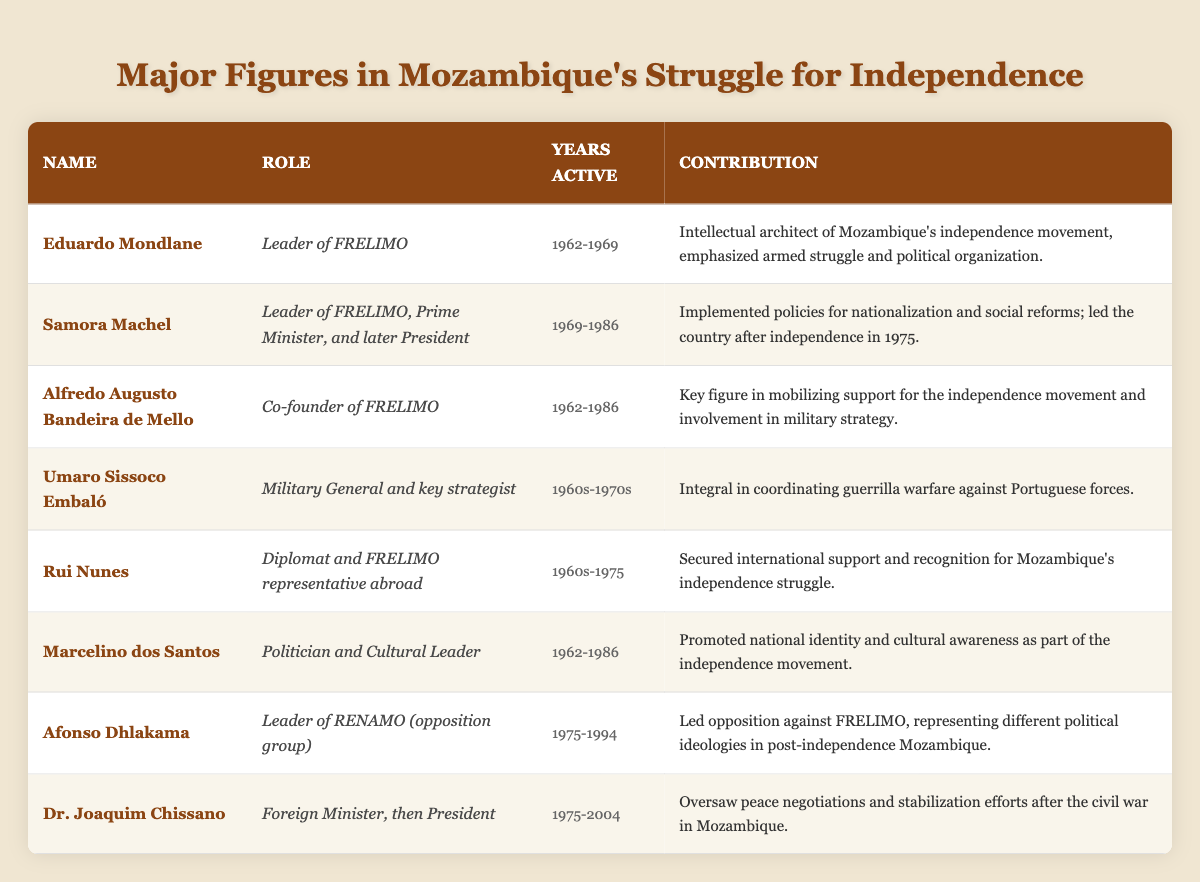What was Eduardo Mondlane's role in Mozambique's independence? According to the table, Eduardo Mondlane served as the "Leader of FRELIMO." This information is directly listed in the corresponding row for his name.
Answer: Leader of FRELIMO Who was the leader of FRELIMO after Eduardo Mondlane? The table indicates that Samora Machel succeeded Eduardo Mondlane as the leader of FRELIMO, effective from 1969, as per the time frames listed under their respective roles.
Answer: Samora Machel How many years was Afonso Dhlakama active in his role? The years active for Afonso Dhlakama are listed as 1975-1994. To find the total active years, we subtract the start year from the end year: 1994 - 1975 = 19.
Answer: 19 years Did Rui Nunes contribute to securing international support for Mozambique? Yes, based on the contribution listed in the table, Rui Nunes is described as having "secured international support and recognition for Mozambique's independence struggle," confirming his relevant role.
Answer: Yes List all the political figures who were active in the 1960s. From the table, examining the years active for each figure reveals that Eduardo Mondlane, Alfredo Augusto Bandeira de Mello, Umaro Sissoco Embaló, and Rui Nunes were all active during this decade. They appear in the rows related to those years.
Answer: Eduardo Mondlane, Alfredo Augusto Bandeira de Mello, Umaro Sissoco Embaló, Rui Nunes Which figure had the longest active years based on the table? By comparing the years active for each figure, Dr. Joaquim Chissano’s active years from 1975 to 2004 total 29 years, which is the longest among those listed. This requires checking each individual's time span to confirm.
Answer: 29 years What main contribution did Samora Machel make after independence? The table states that Samora Machel "implemented policies for nationalization and social reforms" and "led the country after independence in 1975," which highlights his significant post-independence efforts.
Answer: Policies for nationalization and social reforms Which two figures were involved in military strategy? The entries for Alfredo Augusto Bandeira de Mello and Umaro Sissoco Embaló both mention contributions related to military strategy. This is derived by looking at their respective contributions in the table.
Answer: Alfredo Augusto Bandeira de Mello, Umaro Sissoco Embaló 